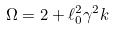<formula> <loc_0><loc_0><loc_500><loc_500>\Omega = 2 + \ell _ { 0 } ^ { 2 } \gamma ^ { 2 } k</formula> 